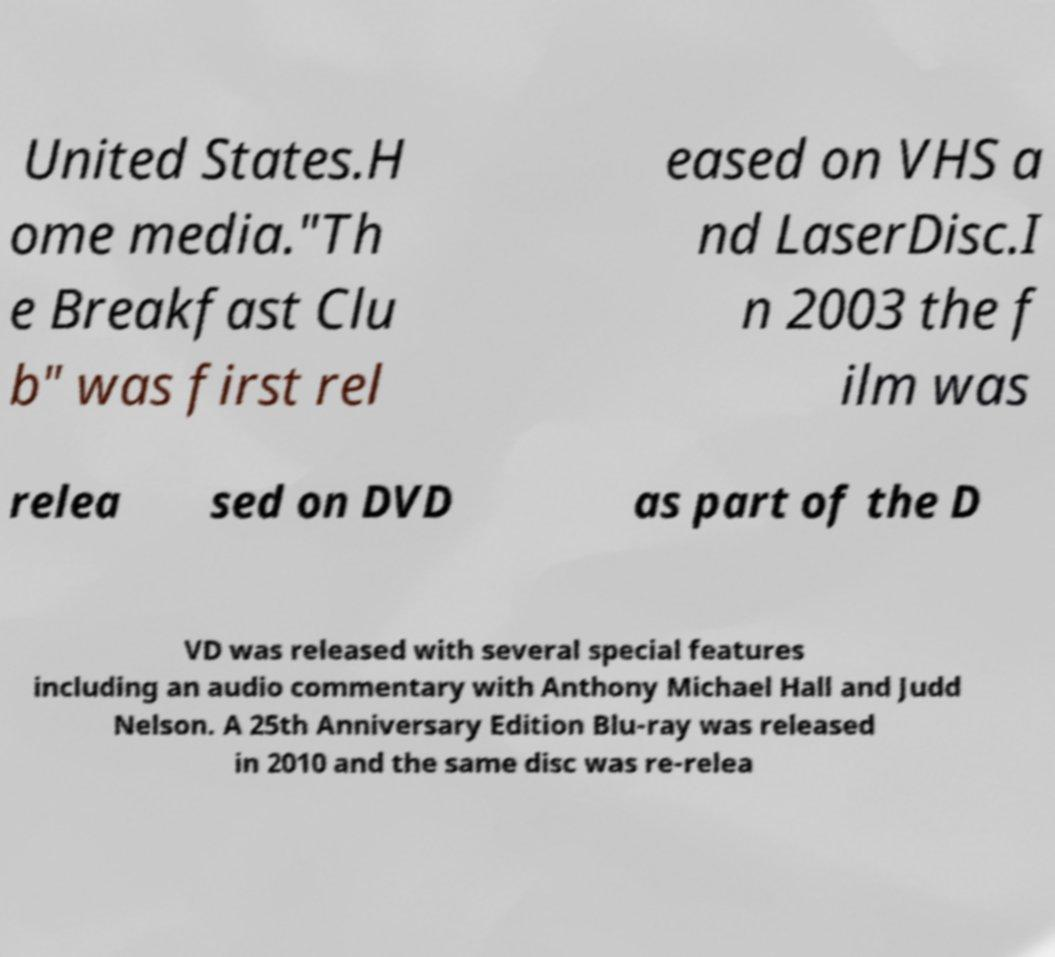Could you assist in decoding the text presented in this image and type it out clearly? United States.H ome media."Th e Breakfast Clu b" was first rel eased on VHS a nd LaserDisc.I n 2003 the f ilm was relea sed on DVD as part of the D VD was released with several special features including an audio commentary with Anthony Michael Hall and Judd Nelson. A 25th Anniversary Edition Blu-ray was released in 2010 and the same disc was re-relea 